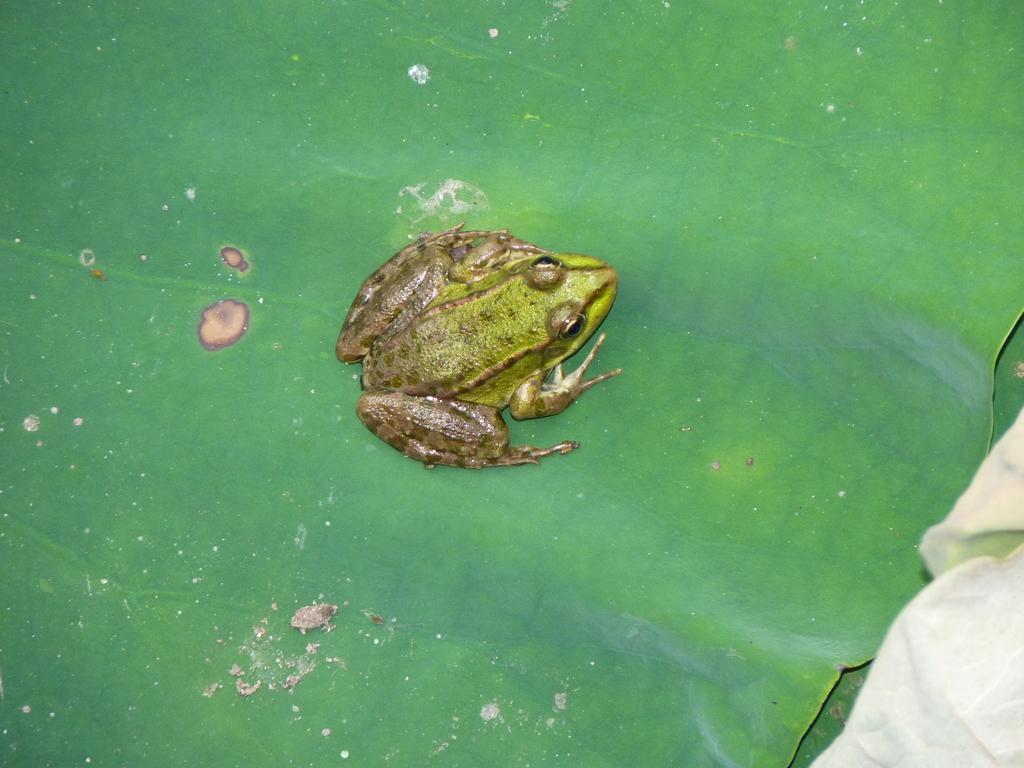Please provide a concise description of this image. In this picture there is a frog in the center of the image, on a leaf and there is a cloth in the bottom right side of the image. 